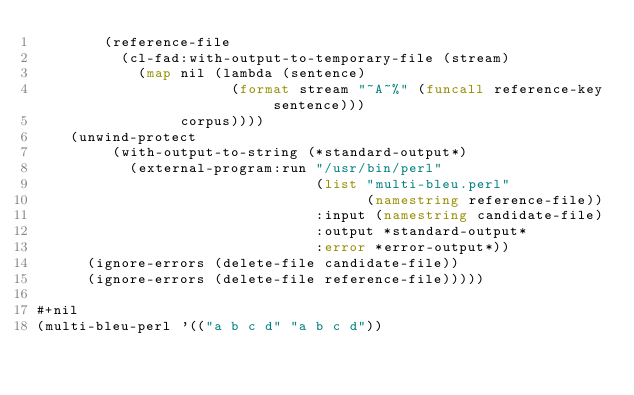Convert code to text. <code><loc_0><loc_0><loc_500><loc_500><_Lisp_>        (reference-file
          (cl-fad:with-output-to-temporary-file (stream)
            (map nil (lambda (sentence)
                       (format stream "~A~%" (funcall reference-key sentence)))
                 corpus))))
    (unwind-protect
         (with-output-to-string (*standard-output*)
           (external-program:run "/usr/bin/perl"
                                 (list "multi-bleu.perl"
                                       (namestring reference-file))
                                 :input (namestring candidate-file)
                                 :output *standard-output*
                                 :error *error-output*))
      (ignore-errors (delete-file candidate-file))
      (ignore-errors (delete-file reference-file)))))

#+nil
(multi-bleu-perl '(("a b c d" "a b c d"))</code> 